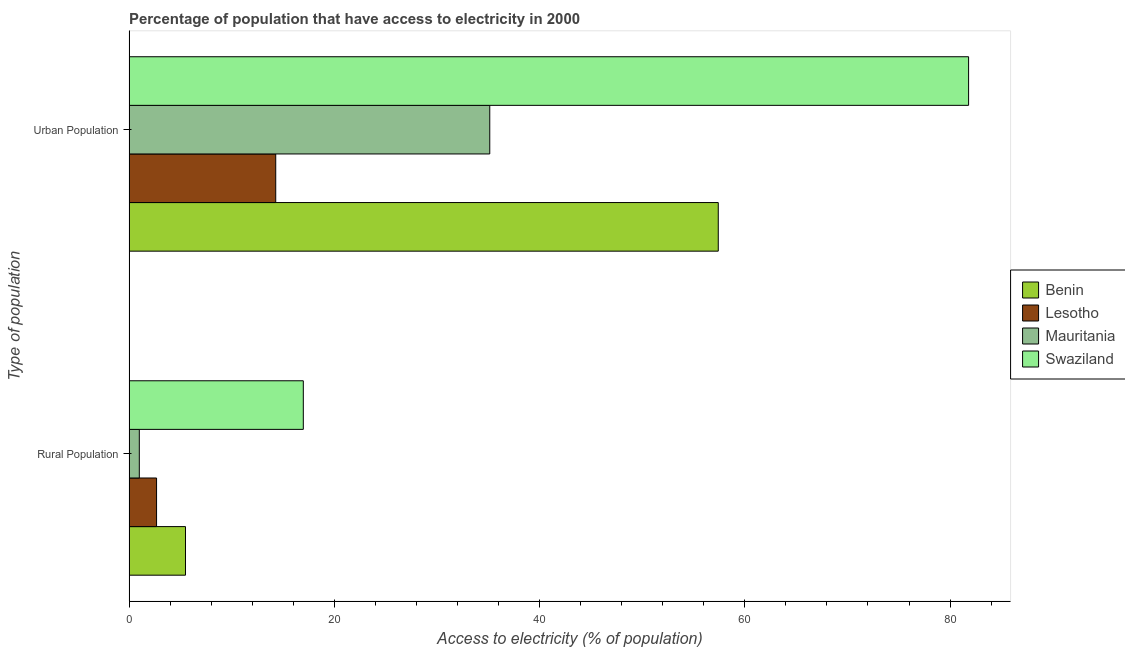Are the number of bars on each tick of the Y-axis equal?
Your answer should be very brief. Yes. How many bars are there on the 1st tick from the top?
Make the answer very short. 4. How many bars are there on the 2nd tick from the bottom?
Make the answer very short. 4. What is the label of the 2nd group of bars from the top?
Keep it short and to the point. Rural Population. What is the percentage of urban population having access to electricity in Lesotho?
Offer a terse response. 14.29. Across all countries, what is the maximum percentage of urban population having access to electricity?
Offer a very short reply. 81.81. In which country was the percentage of urban population having access to electricity maximum?
Offer a terse response. Swaziland. In which country was the percentage of urban population having access to electricity minimum?
Your answer should be compact. Lesotho. What is the total percentage of rural population having access to electricity in the graph?
Offer a terse response. 26.16. What is the difference between the percentage of urban population having access to electricity in Mauritania and that in Lesotho?
Your answer should be very brief. 20.86. What is the difference between the percentage of rural population having access to electricity in Lesotho and the percentage of urban population having access to electricity in Mauritania?
Your answer should be compact. -32.47. What is the average percentage of urban population having access to electricity per country?
Keep it short and to the point. 47.17. What is the difference between the percentage of rural population having access to electricity and percentage of urban population having access to electricity in Mauritania?
Offer a very short reply. -34.15. In how many countries, is the percentage of urban population having access to electricity greater than 76 %?
Offer a very short reply. 1. What is the ratio of the percentage of urban population having access to electricity in Lesotho to that in Mauritania?
Make the answer very short. 0.41. What does the 3rd bar from the top in Rural Population represents?
Make the answer very short. Lesotho. What does the 4th bar from the bottom in Urban Population represents?
Offer a terse response. Swaziland. Are all the bars in the graph horizontal?
Your answer should be very brief. Yes. How many countries are there in the graph?
Keep it short and to the point. 4. What is the difference between two consecutive major ticks on the X-axis?
Keep it short and to the point. 20. Are the values on the major ticks of X-axis written in scientific E-notation?
Your answer should be compact. No. Does the graph contain any zero values?
Keep it short and to the point. No. Does the graph contain grids?
Your answer should be very brief. No. How many legend labels are there?
Your response must be concise. 4. How are the legend labels stacked?
Your answer should be compact. Vertical. What is the title of the graph?
Give a very brief answer. Percentage of population that have access to electricity in 2000. Does "Japan" appear as one of the legend labels in the graph?
Give a very brief answer. No. What is the label or title of the X-axis?
Provide a short and direct response. Access to electricity (% of population). What is the label or title of the Y-axis?
Your answer should be compact. Type of population. What is the Access to electricity (% of population) in Benin in Rural Population?
Your answer should be compact. 5.5. What is the Access to electricity (% of population) of Lesotho in Rural Population?
Your answer should be very brief. 2.68. What is the Access to electricity (% of population) of Swaziland in Rural Population?
Your answer should be compact. 16.98. What is the Access to electricity (% of population) of Benin in Urban Population?
Offer a very short reply. 57.41. What is the Access to electricity (% of population) in Lesotho in Urban Population?
Your answer should be compact. 14.29. What is the Access to electricity (% of population) in Mauritania in Urban Population?
Your answer should be compact. 35.15. What is the Access to electricity (% of population) of Swaziland in Urban Population?
Ensure brevity in your answer.  81.81. Across all Type of population, what is the maximum Access to electricity (% of population) of Benin?
Offer a very short reply. 57.41. Across all Type of population, what is the maximum Access to electricity (% of population) of Lesotho?
Provide a short and direct response. 14.29. Across all Type of population, what is the maximum Access to electricity (% of population) in Mauritania?
Your response must be concise. 35.15. Across all Type of population, what is the maximum Access to electricity (% of population) of Swaziland?
Make the answer very short. 81.81. Across all Type of population, what is the minimum Access to electricity (% of population) in Lesotho?
Offer a very short reply. 2.68. Across all Type of population, what is the minimum Access to electricity (% of population) in Mauritania?
Keep it short and to the point. 1. Across all Type of population, what is the minimum Access to electricity (% of population) of Swaziland?
Your answer should be very brief. 16.98. What is the total Access to electricity (% of population) of Benin in the graph?
Offer a very short reply. 62.91. What is the total Access to electricity (% of population) in Lesotho in the graph?
Your answer should be very brief. 16.97. What is the total Access to electricity (% of population) in Mauritania in the graph?
Give a very brief answer. 36.15. What is the total Access to electricity (% of population) of Swaziland in the graph?
Provide a succinct answer. 98.79. What is the difference between the Access to electricity (% of population) of Benin in Rural Population and that in Urban Population?
Your answer should be very brief. -51.91. What is the difference between the Access to electricity (% of population) in Lesotho in Rural Population and that in Urban Population?
Offer a very short reply. -11.61. What is the difference between the Access to electricity (% of population) of Mauritania in Rural Population and that in Urban Population?
Keep it short and to the point. -34.15. What is the difference between the Access to electricity (% of population) of Swaziland in Rural Population and that in Urban Population?
Ensure brevity in your answer.  -64.83. What is the difference between the Access to electricity (% of population) of Benin in Rural Population and the Access to electricity (% of population) of Lesotho in Urban Population?
Ensure brevity in your answer.  -8.79. What is the difference between the Access to electricity (% of population) in Benin in Rural Population and the Access to electricity (% of population) in Mauritania in Urban Population?
Give a very brief answer. -29.65. What is the difference between the Access to electricity (% of population) in Benin in Rural Population and the Access to electricity (% of population) in Swaziland in Urban Population?
Your answer should be compact. -76.31. What is the difference between the Access to electricity (% of population) of Lesotho in Rural Population and the Access to electricity (% of population) of Mauritania in Urban Population?
Your answer should be very brief. -32.47. What is the difference between the Access to electricity (% of population) of Lesotho in Rural Population and the Access to electricity (% of population) of Swaziland in Urban Population?
Your answer should be compact. -79.13. What is the difference between the Access to electricity (% of population) of Mauritania in Rural Population and the Access to electricity (% of population) of Swaziland in Urban Population?
Give a very brief answer. -80.81. What is the average Access to electricity (% of population) in Benin per Type of population?
Your response must be concise. 31.46. What is the average Access to electricity (% of population) of Lesotho per Type of population?
Ensure brevity in your answer.  8.49. What is the average Access to electricity (% of population) in Mauritania per Type of population?
Your answer should be compact. 18.07. What is the average Access to electricity (% of population) of Swaziland per Type of population?
Offer a very short reply. 49.39. What is the difference between the Access to electricity (% of population) of Benin and Access to electricity (% of population) of Lesotho in Rural Population?
Provide a succinct answer. 2.82. What is the difference between the Access to electricity (% of population) of Benin and Access to electricity (% of population) of Mauritania in Rural Population?
Keep it short and to the point. 4.5. What is the difference between the Access to electricity (% of population) in Benin and Access to electricity (% of population) in Swaziland in Rural Population?
Provide a short and direct response. -11.48. What is the difference between the Access to electricity (% of population) of Lesotho and Access to electricity (% of population) of Mauritania in Rural Population?
Your answer should be very brief. 1.68. What is the difference between the Access to electricity (% of population) of Lesotho and Access to electricity (% of population) of Swaziland in Rural Population?
Offer a very short reply. -14.3. What is the difference between the Access to electricity (% of population) in Mauritania and Access to electricity (% of population) in Swaziland in Rural Population?
Your answer should be very brief. -15.98. What is the difference between the Access to electricity (% of population) in Benin and Access to electricity (% of population) in Lesotho in Urban Population?
Give a very brief answer. 43.12. What is the difference between the Access to electricity (% of population) of Benin and Access to electricity (% of population) of Mauritania in Urban Population?
Keep it short and to the point. 22.26. What is the difference between the Access to electricity (% of population) of Benin and Access to electricity (% of population) of Swaziland in Urban Population?
Make the answer very short. -24.39. What is the difference between the Access to electricity (% of population) of Lesotho and Access to electricity (% of population) of Mauritania in Urban Population?
Give a very brief answer. -20.86. What is the difference between the Access to electricity (% of population) of Lesotho and Access to electricity (% of population) of Swaziland in Urban Population?
Make the answer very short. -67.51. What is the difference between the Access to electricity (% of population) in Mauritania and Access to electricity (% of population) in Swaziland in Urban Population?
Provide a succinct answer. -46.66. What is the ratio of the Access to electricity (% of population) in Benin in Rural Population to that in Urban Population?
Ensure brevity in your answer.  0.1. What is the ratio of the Access to electricity (% of population) in Lesotho in Rural Population to that in Urban Population?
Your answer should be very brief. 0.19. What is the ratio of the Access to electricity (% of population) in Mauritania in Rural Population to that in Urban Population?
Offer a terse response. 0.03. What is the ratio of the Access to electricity (% of population) in Swaziland in Rural Population to that in Urban Population?
Ensure brevity in your answer.  0.21. What is the difference between the highest and the second highest Access to electricity (% of population) of Benin?
Your response must be concise. 51.91. What is the difference between the highest and the second highest Access to electricity (% of population) in Lesotho?
Keep it short and to the point. 11.61. What is the difference between the highest and the second highest Access to electricity (% of population) of Mauritania?
Your answer should be very brief. 34.15. What is the difference between the highest and the second highest Access to electricity (% of population) in Swaziland?
Keep it short and to the point. 64.83. What is the difference between the highest and the lowest Access to electricity (% of population) in Benin?
Your response must be concise. 51.91. What is the difference between the highest and the lowest Access to electricity (% of population) in Lesotho?
Your response must be concise. 11.61. What is the difference between the highest and the lowest Access to electricity (% of population) in Mauritania?
Your response must be concise. 34.15. What is the difference between the highest and the lowest Access to electricity (% of population) of Swaziland?
Keep it short and to the point. 64.83. 